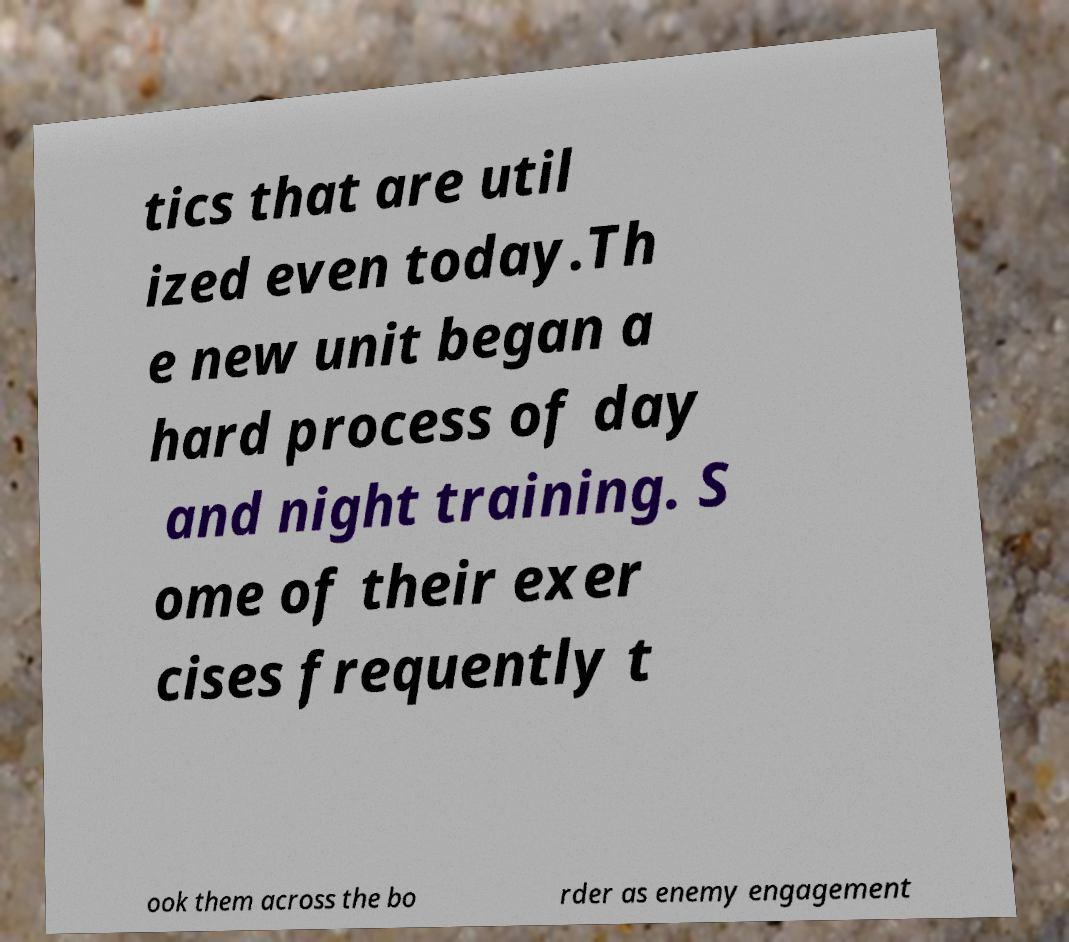Can you read and provide the text displayed in the image?This photo seems to have some interesting text. Can you extract and type it out for me? tics that are util ized even today.Th e new unit began a hard process of day and night training. S ome of their exer cises frequently t ook them across the bo rder as enemy engagement 